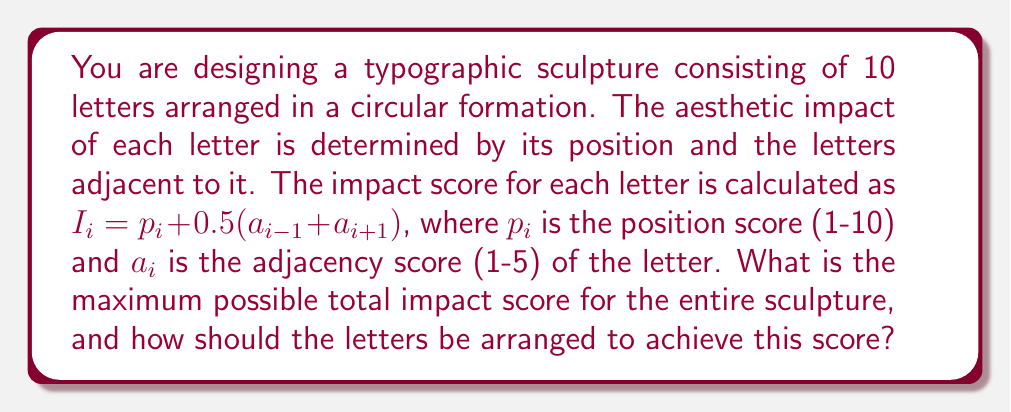Could you help me with this problem? To solve this problem, we need to maximize the total impact score of the sculpture. Let's approach this step-by-step:

1) The total impact score is the sum of individual letter scores:

   $$I_{total} = \sum_{i=1}^{10} I_i = \sum_{i=1}^{10} (p_i + 0.5(a_{i-1} + a_{i+1}))$$

2) To maximize this, we need to maximize each component:
   - Position scores ($p_i$): These are fixed from 1 to 10.
   - Adjacency scores ($a_i$): These can be optimized.

3) The optimal arrangement will have the highest adjacency scores next to the highest position scores. In a circular arrangement, each letter affects two others.

4) The optimal arrangement is:
   - Highest position score (10) with highest adjacency scores (5, 5)
   - Second highest (9) with next highest adjacency scores (5, 4)
   - Third highest (8) with (4, 4)
   - And so on...

5) Let's calculate the impact scores:
   $$I_{10} = 10 + 0.5(5 + 5) = 15$$
   $$I_9 = 9 + 0.5(5 + 4) = 13.5$$
   $$I_8 = 8 + 0.5(4 + 4) = 12$$
   $$I_7 = 7 + 0.5(4 + 3) = 10.5$$
   $$I_6 = 6 + 0.5(3 + 3) = 9$$
   $$I_5 = 5 + 0.5(3 + 2) = 7.5$$
   $$I_4 = 4 + 0.5(2 + 2) = 6$$
   $$I_3 = 3 + 0.5(2 + 1) = 4.5$$
   $$I_2 = 2 + 0.5(1 + 1) = 3$$
   $$I_1 = 1 + 0.5(1 + 5) = 4$$

6) The total maximum impact score is the sum of these:

   $$I_{total} = 15 + 13.5 + 12 + 10.5 + 9 + 7.5 + 6 + 4.5 + 3 + 4 = 85$$
Answer: 85 